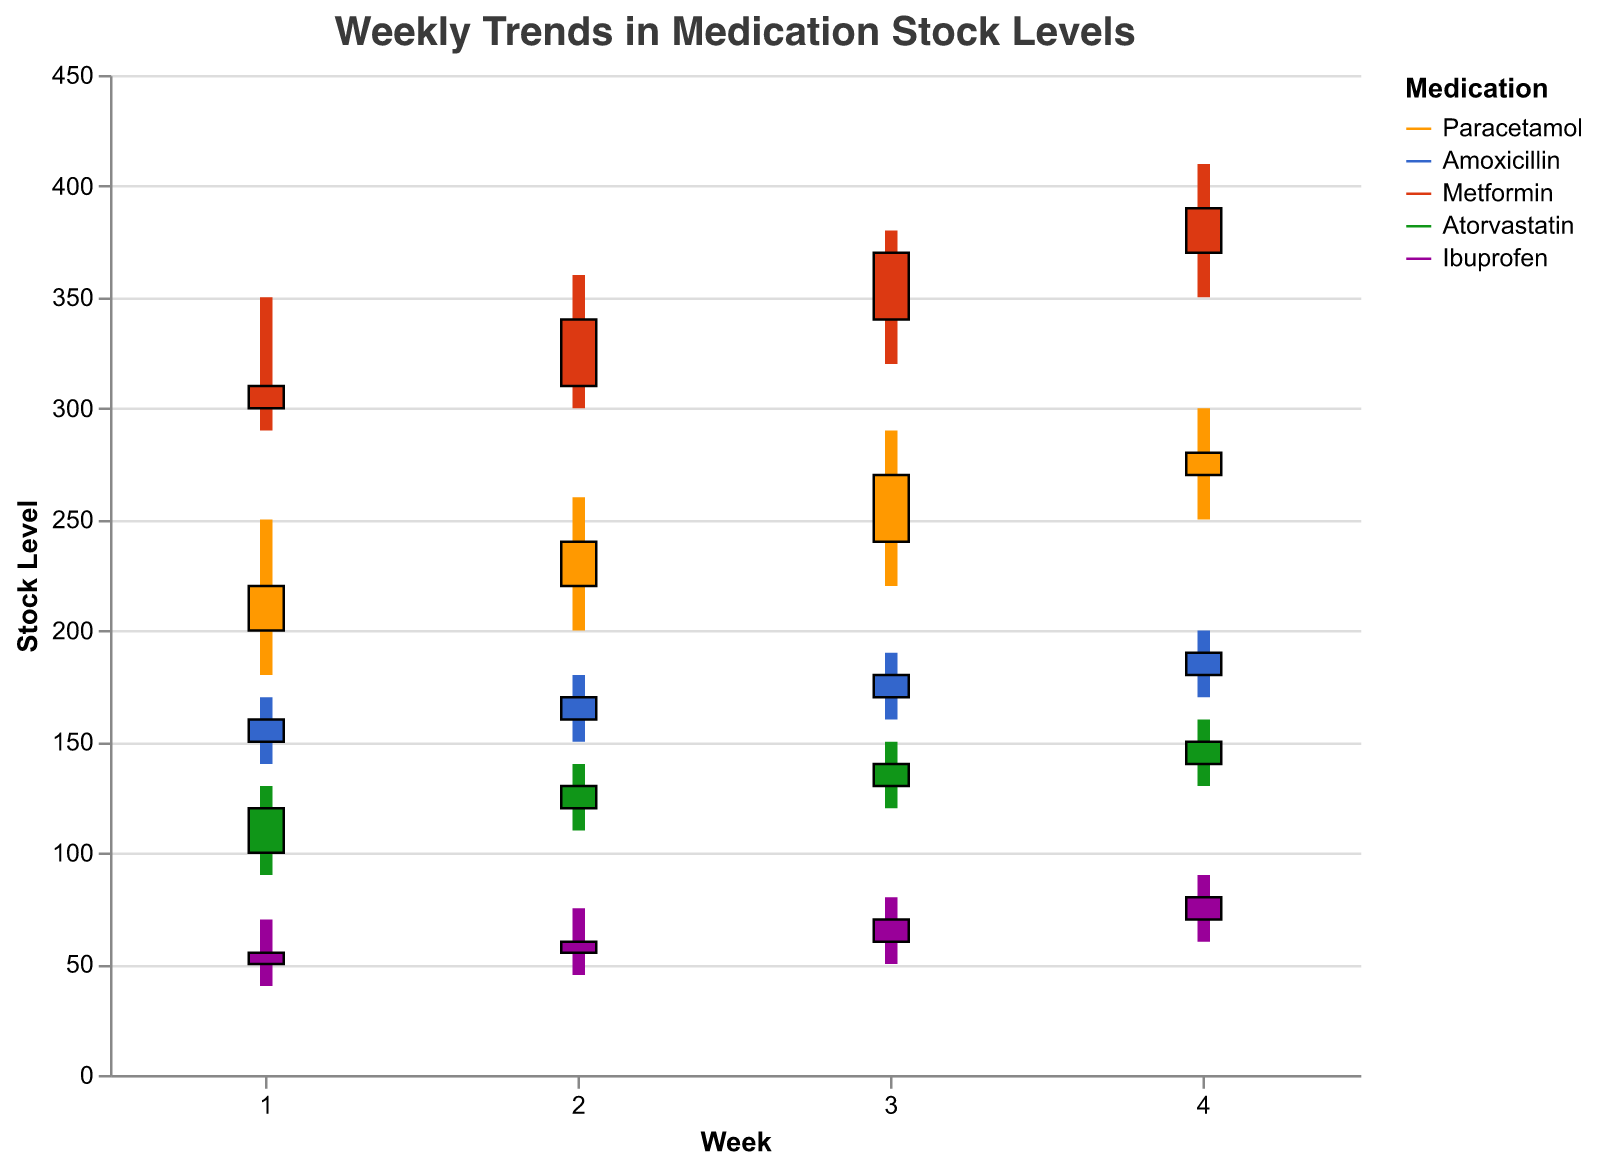What's the title of the plot? The title is typically found at the top of a plot and provides a summary of what the plot represents. In this case, the title reads "Weekly Trends in Medication Stock Levels".
Answer: Weekly Trends in Medication Stock Levels What is the highest stock level for Paracetamol in any week? Identify the highest value from the 'High' column for Paracetamol. From the visual graph, this value is 300 in the fourth week.
Answer: 300 Which medication has the lowest opening stock level in the first week? Look at the 'Opening' values for each medication in the first week. Ibuprofen has the lowest opening stock level with a value of 50.
Answer: Ibuprofen How did the stock level of Metformin change from Week 2 to Week 3? Compare the 'Closing' value for Metformin in Week 2, which is 340, with the 'Opening' value in Week 3, which is 340. Therefore, the stock level did not change at the opening, but the actual trend should be recognized visually for further changes.
Answer: No change initially What is the trend in stock levels for Ibuprofen over 4 weeks? Observe the 'Closing' stock levels for Ibuprofen in all four weeks: 55, 60, 70, 80. It shows a consistent increase over the weeks.
Answer: Increasing Which medication had the most significant increase in stock from Week 1 to Week 4? Calculate the difference between the 'Closing' stock levels in Week 4 and the 'Opening' stock levels in Week 1 for each medication. Metformin had the most notable increase from 300 to 390, which is an increase of 90 units.
Answer: Metformin Which week had the highest overall stock level for all medications combined? Sum the 'High' values for all medications in each week. Week 4 has the total combined highest values through visual observation.
Answer: Week 4 How does the stock volatility of Atorvastatin compare to that of Amoxicillin over the 4 weeks? Compare the highest and lowest stock levels ('High' and 'Low' values) for Atorvastatin and Amoxicillin. Atorvastatin ranges from 90 to 160, while Amoxicillin ranges from 140 to 200. Hence, Atorvastatin has greater volatility.
Answer: Atorvastatin more volatile What is the closing stock difference between Paracetamol and Metformin in the last week? Subtract the 'Closing' level of Metformin from Paracetamol for the last week (280 for Paracetamol and 390 for Metformin). The difference is calculated as 280 - 390 = -110.
Answer: -110 